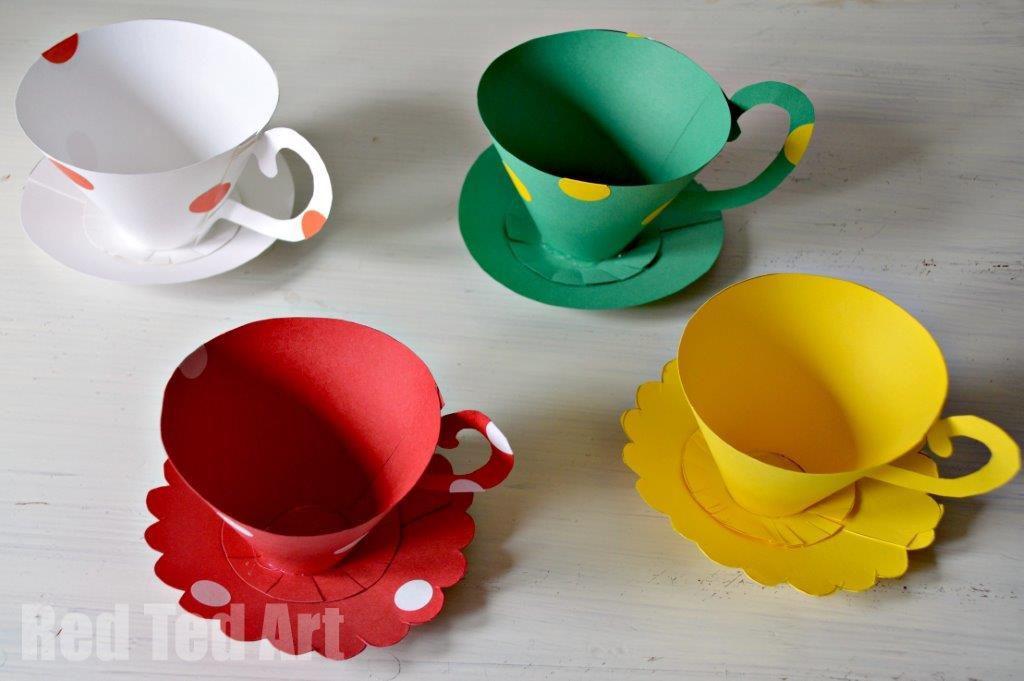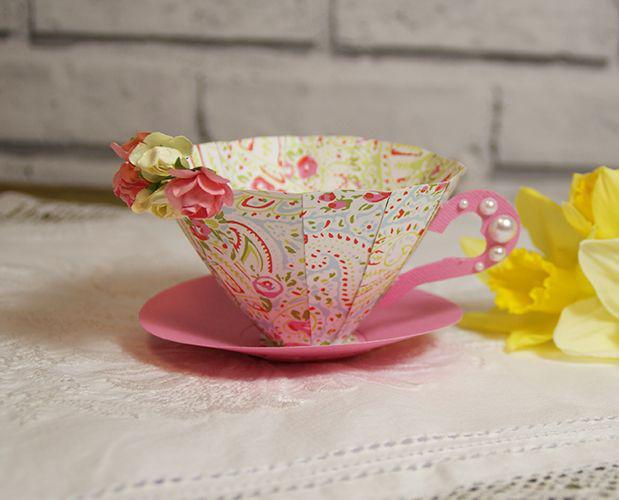The first image is the image on the left, the second image is the image on the right. For the images displayed, is the sentence "There are multiple paper cups on the left, but only one on the right." factually correct? Answer yes or no. Yes. The first image is the image on the left, the second image is the image on the right. Evaluate the accuracy of this statement regarding the images: "There is at least one tower of four paper plates.". Is it true? Answer yes or no. No. 